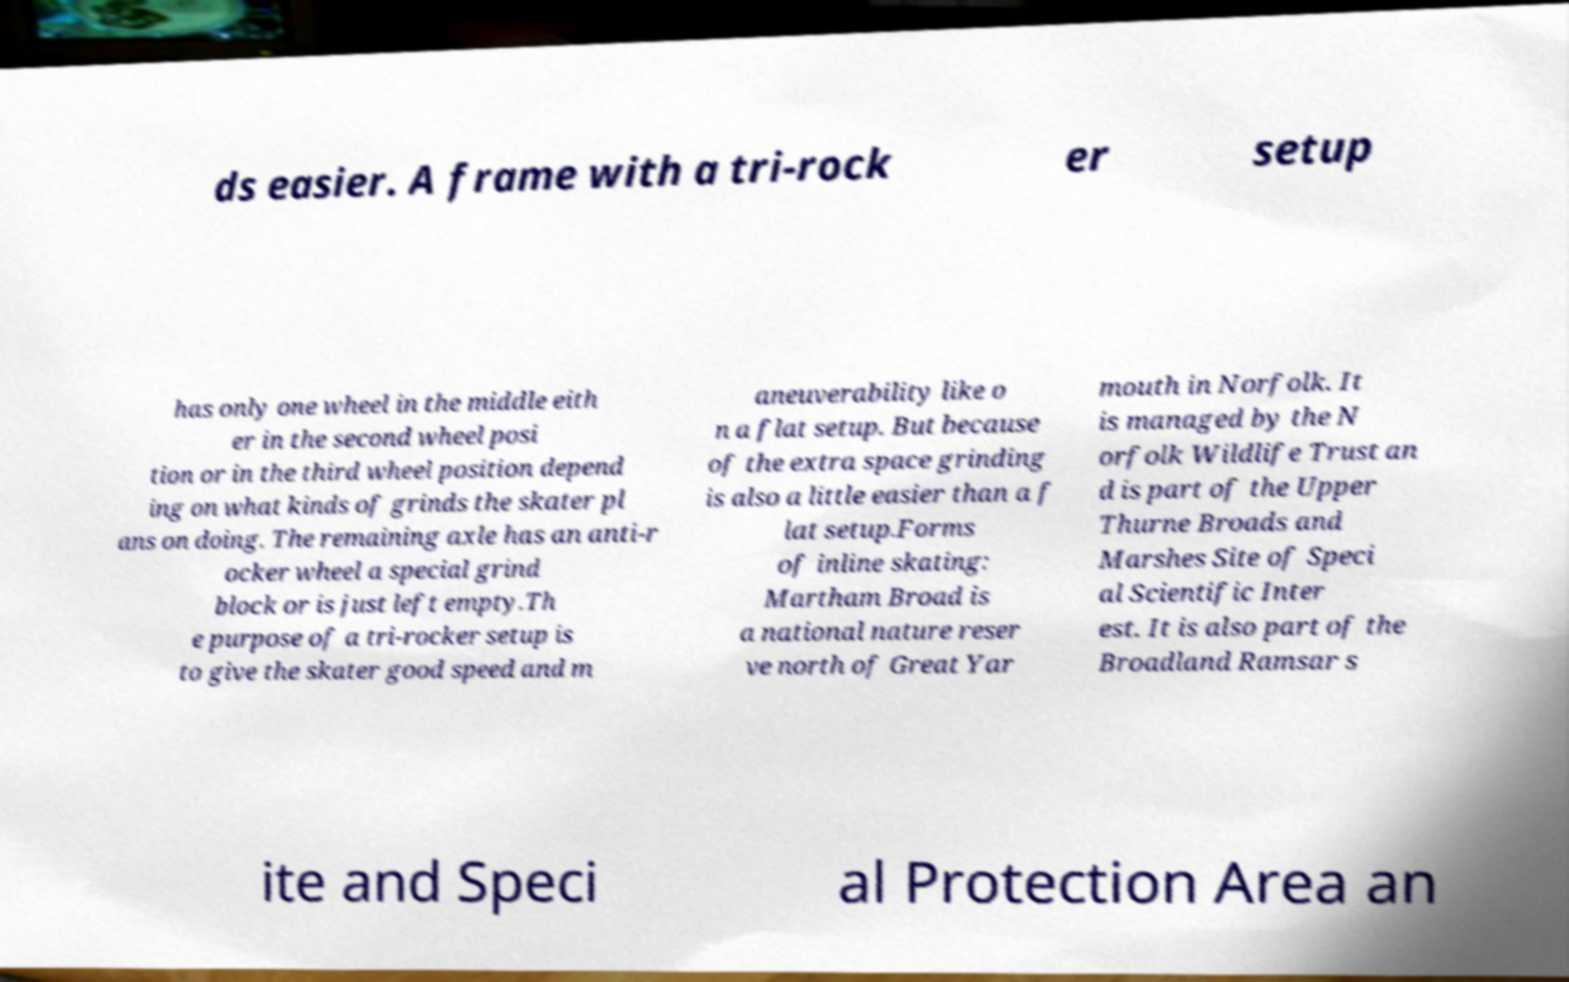Can you read and provide the text displayed in the image?This photo seems to have some interesting text. Can you extract and type it out for me? ds easier. A frame with a tri-rock er setup has only one wheel in the middle eith er in the second wheel posi tion or in the third wheel position depend ing on what kinds of grinds the skater pl ans on doing. The remaining axle has an anti-r ocker wheel a special grind block or is just left empty.Th e purpose of a tri-rocker setup is to give the skater good speed and m aneuverability like o n a flat setup. But because of the extra space grinding is also a little easier than a f lat setup.Forms of inline skating: Martham Broad is a national nature reser ve north of Great Yar mouth in Norfolk. It is managed by the N orfolk Wildlife Trust an d is part of the Upper Thurne Broads and Marshes Site of Speci al Scientific Inter est. It is also part of the Broadland Ramsar s ite and Speci al Protection Area an 